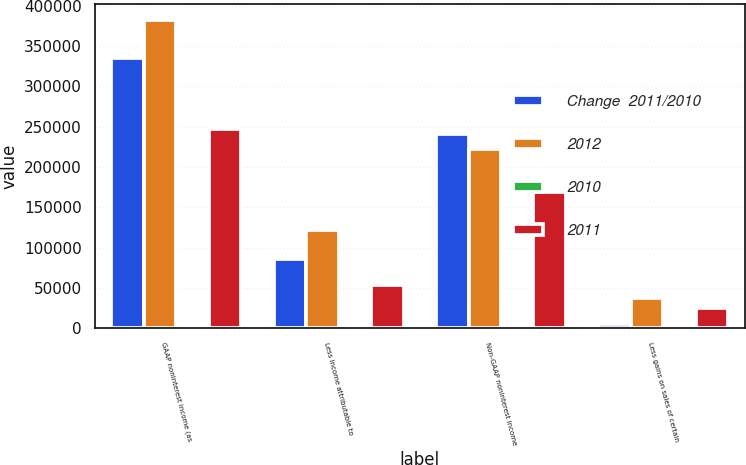<chart> <loc_0><loc_0><loc_500><loc_500><stacked_bar_chart><ecel><fcel>GAAP noninterest income (as<fcel>Less income attributable to<fcel>Non-GAAP noninterest income<fcel>Less gains on sales of certain<nl><fcel>Change  2011/2010<fcel>335546<fcel>85940<fcel>240408<fcel>4955<nl><fcel>2012<fcel>382332<fcel>122336<fcel>222682<fcel>37314<nl><fcel>2010<fcel>12.2<fcel>29.8<fcel>8<fcel>86.7<nl><fcel>2011<fcel>247530<fcel>54186<fcel>168645<fcel>24699<nl></chart> 